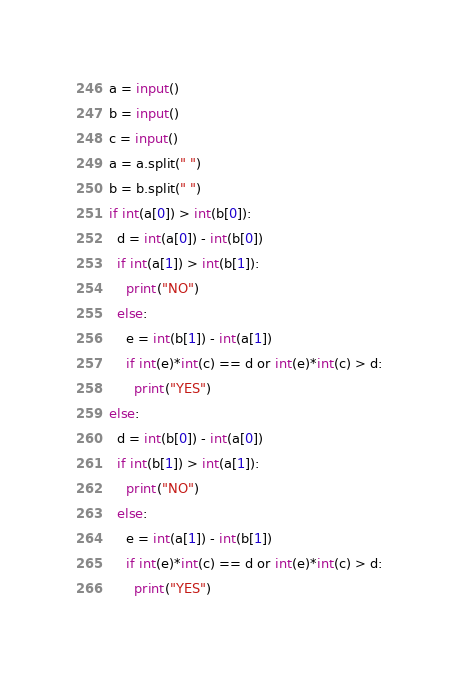<code> <loc_0><loc_0><loc_500><loc_500><_Python_>a = input()
b = input()
c = input()
a = a.split(" ")
b = b.split(" ")
if int(a[0]) > int(b[0]):
  d = int(a[0]) - int(b[0])
  if int(a[1]) > int(b[1]):
    print("NO")
  else:
    e = int(b[1]) - int(a[1])
    if int(e)*int(c) == d or int(e)*int(c) > d:
      print("YES")
else:
  d = int(b[0]) - int(a[0])
  if int(b[1]) > int(a[1]):
    print("NO")
  else:
    e = int(a[1]) - int(b[1])
    if int(e)*int(c) == d or int(e)*int(c) > d:
      print("YES")</code> 